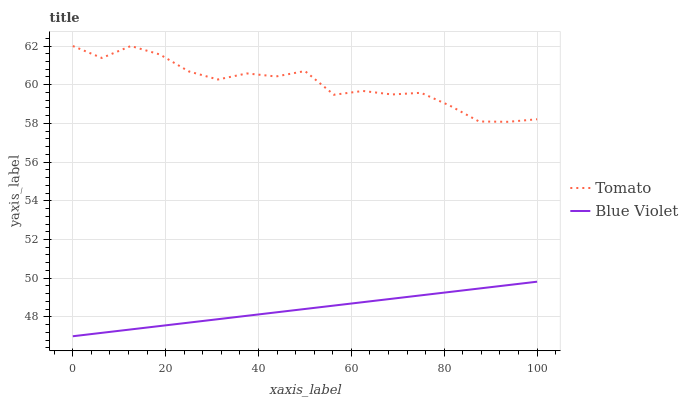Does Blue Violet have the minimum area under the curve?
Answer yes or no. Yes. Does Tomato have the maximum area under the curve?
Answer yes or no. Yes. Does Blue Violet have the maximum area under the curve?
Answer yes or no. No. Is Blue Violet the smoothest?
Answer yes or no. Yes. Is Tomato the roughest?
Answer yes or no. Yes. Is Blue Violet the roughest?
Answer yes or no. No. Does Blue Violet have the lowest value?
Answer yes or no. Yes. Does Tomato have the highest value?
Answer yes or no. Yes. Does Blue Violet have the highest value?
Answer yes or no. No. Is Blue Violet less than Tomato?
Answer yes or no. Yes. Is Tomato greater than Blue Violet?
Answer yes or no. Yes. Does Blue Violet intersect Tomato?
Answer yes or no. No. 